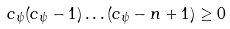<formula> <loc_0><loc_0><loc_500><loc_500>c _ { \psi } ( c _ { \psi } - 1 ) \dots ( c _ { \psi } - n + 1 ) \geq 0</formula> 